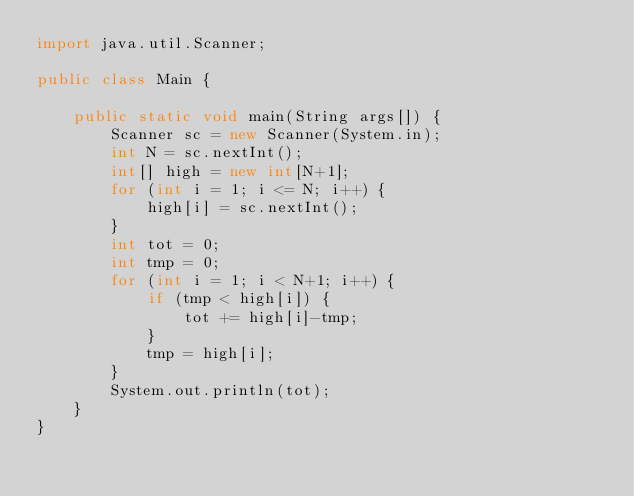<code> <loc_0><loc_0><loc_500><loc_500><_Java_>import java.util.Scanner;

public class Main {

    public static void main(String args[]) {
        Scanner sc = new Scanner(System.in);
        int N = sc.nextInt();
        int[] high = new int[N+1];
        for (int i = 1; i <= N; i++) {
            high[i] = sc.nextInt();
        }
        int tot = 0;
        int tmp = 0;
        for (int i = 1; i < N+1; i++) {
            if (tmp < high[i]) {
                tot += high[i]-tmp;
            }
            tmp = high[i];
        }
        System.out.println(tot);
    }
}</code> 